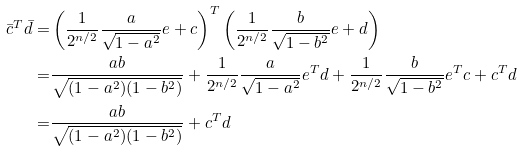<formula> <loc_0><loc_0><loc_500><loc_500>\bar { c } ^ { T } \bar { d } = & \left ( \frac { 1 } { 2 ^ { n / 2 } } \frac { a } { \sqrt { 1 - a ^ { 2 } } } e + c \right ) ^ { T } \left ( \frac { 1 } { 2 ^ { n / 2 } } \frac { b } { \sqrt { 1 - b ^ { 2 } } } e + d \right ) \\ = & \frac { a b } { \sqrt { ( 1 - a ^ { 2 } ) ( 1 - b ^ { 2 } ) } } + \frac { 1 } { 2 ^ { n / 2 } } \frac { a } { \sqrt { 1 - a ^ { 2 } } } e ^ { T } d + \frac { 1 } { 2 ^ { n / 2 } } \frac { b } { \sqrt { 1 - b ^ { 2 } } } e ^ { T } c + c ^ { T } d \\ = & \frac { a b } { \sqrt { ( 1 - a ^ { 2 } ) ( 1 - b ^ { 2 } ) } } + c ^ { T } d</formula> 